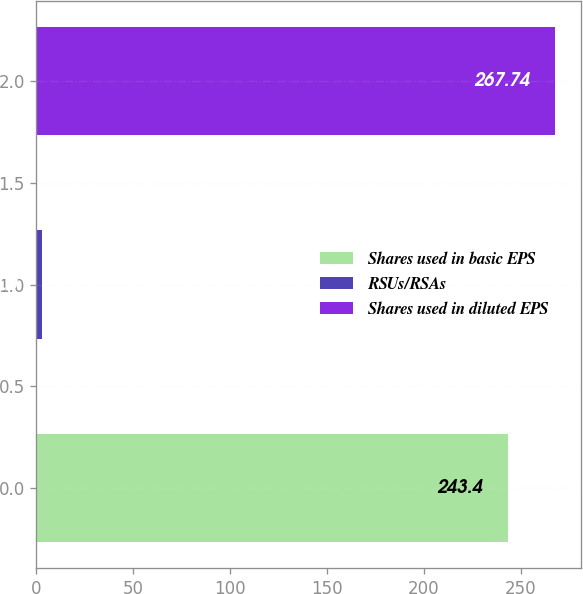<chart> <loc_0><loc_0><loc_500><loc_500><bar_chart><fcel>Shares used in basic EPS<fcel>RSUs/RSAs<fcel>Shares used in diluted EPS<nl><fcel>243.4<fcel>3<fcel>267.74<nl></chart> 